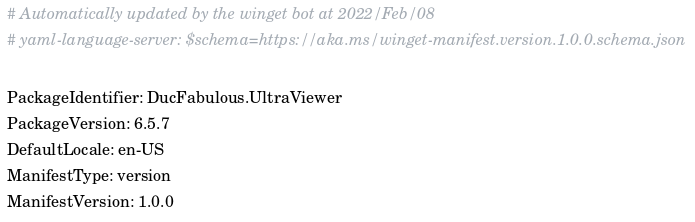<code> <loc_0><loc_0><loc_500><loc_500><_YAML_># Automatically updated by the winget bot at 2022/Feb/08
# yaml-language-server: $schema=https://aka.ms/winget-manifest.version.1.0.0.schema.json

PackageIdentifier: DucFabulous.UltraViewer
PackageVersion: 6.5.7
DefaultLocale: en-US
ManifestType: version
ManifestVersion: 1.0.0
</code> 